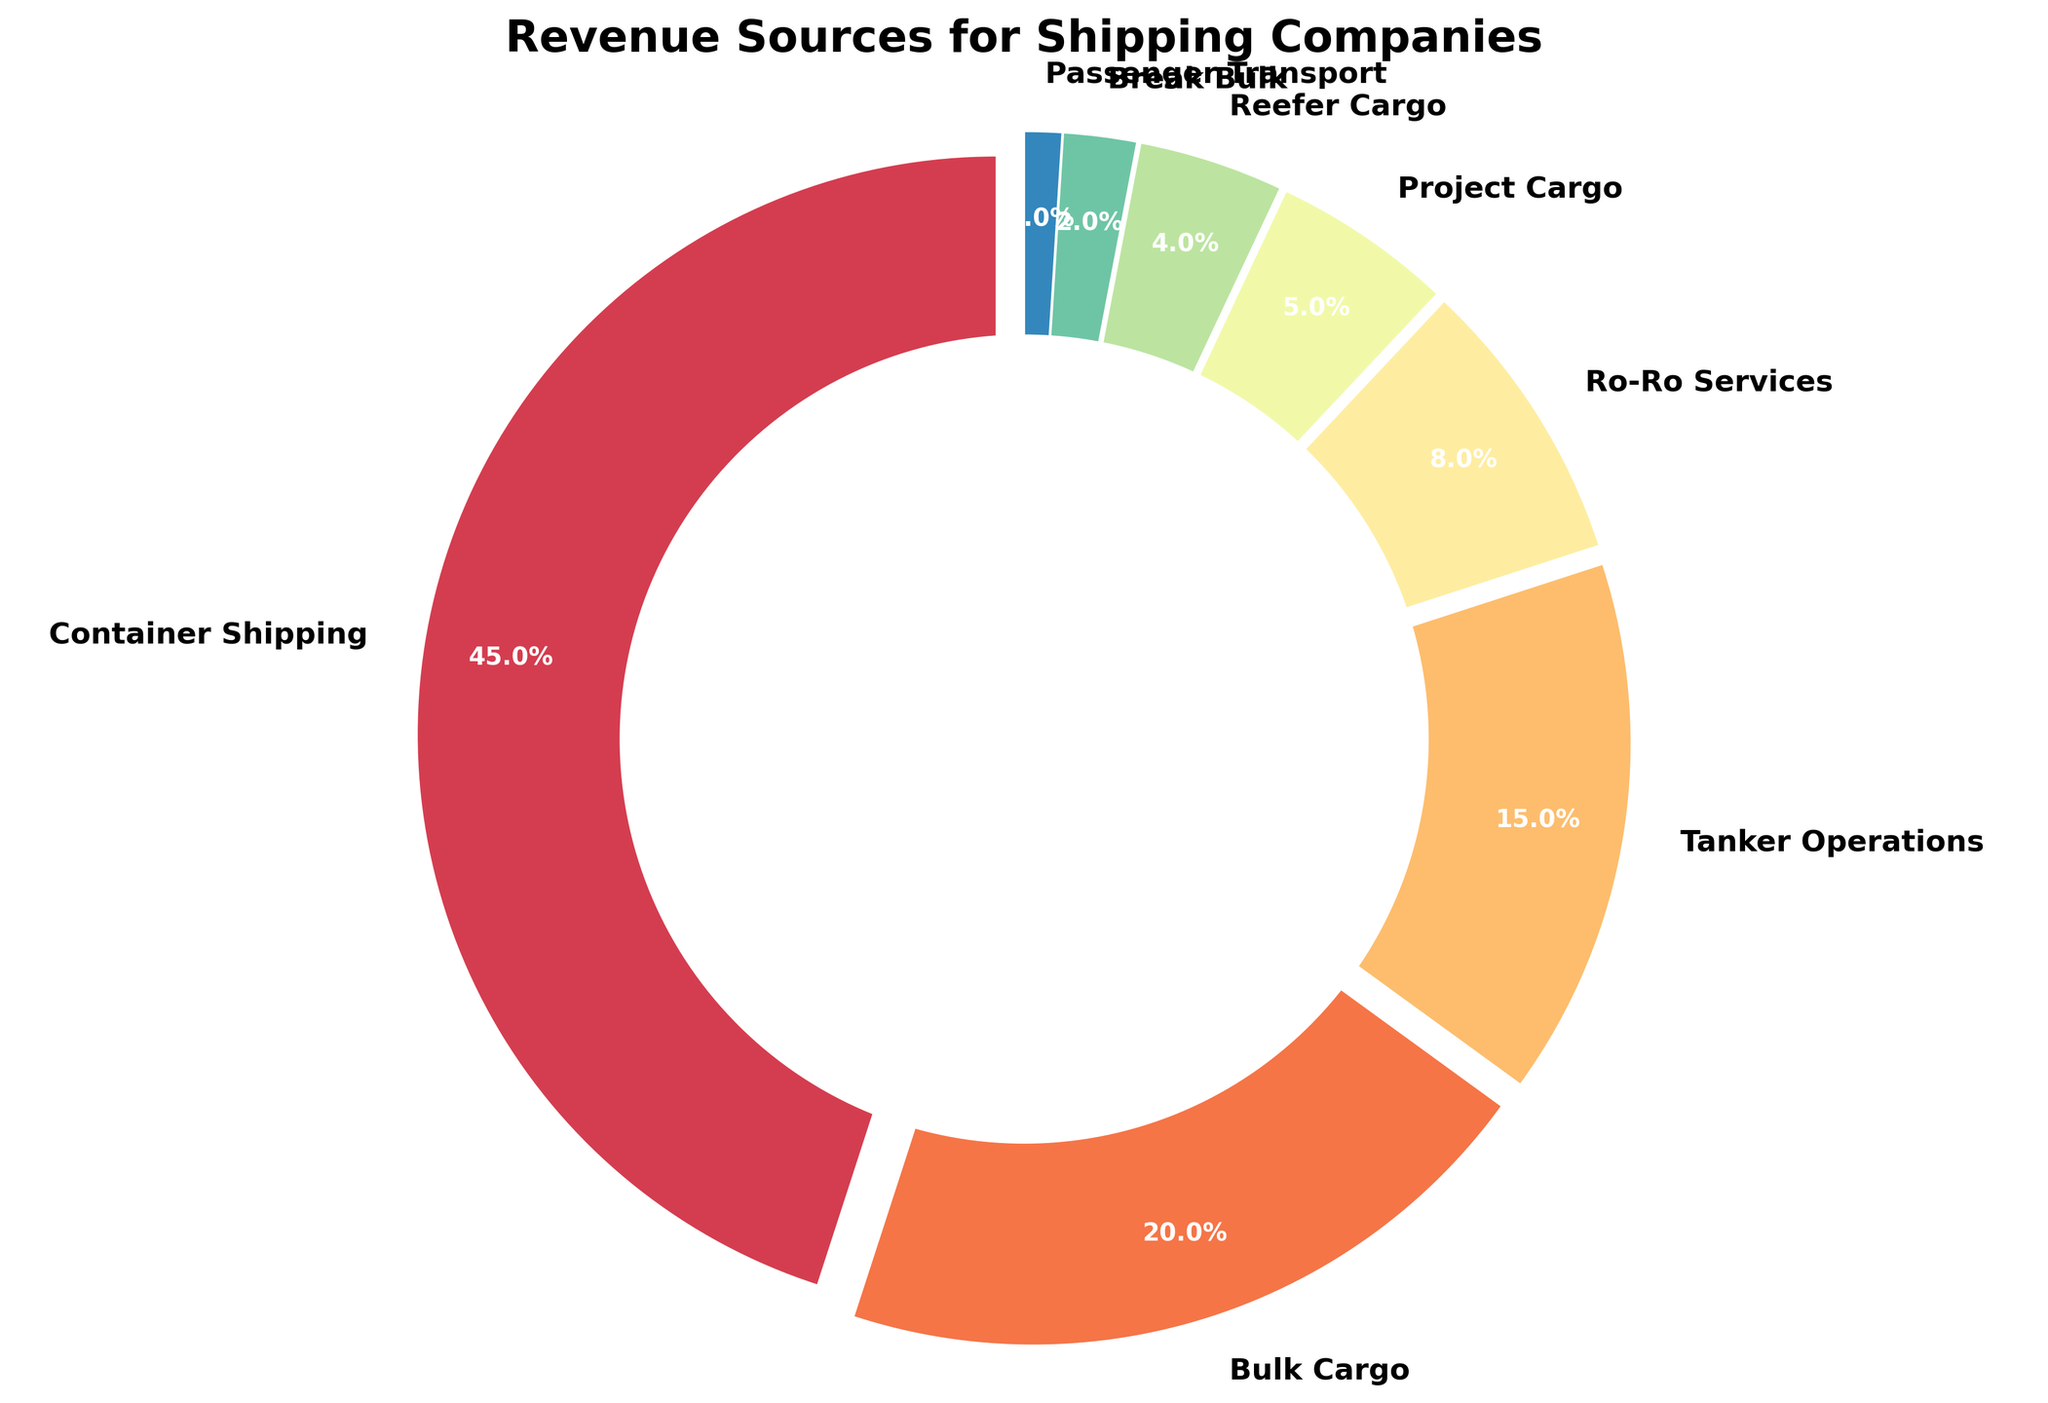What is the largest revenue source for shipping companies? Looking at the pie chart, Container Shipping has the largest slice, which shows it is the largest revenue source.
Answer: Container Shipping What percentage of revenue comes from Bulk Cargo compared to Ro-Ro Services? Bulk Cargo makes up 20% of the revenue while Ro-Ro Services account for 8%. Therefore, Bulk Cargo's share is more significant.
Answer: Bulk Cargo: 20%, Ro-Ro Services: 8% If you combine the revenue percentages of Project Cargo and Reefer Cargo, how does it compare to Tanker Operations? Project Cargo and Reefer Cargo add up to 5% + 4% = 9%. Tanker Operations alone contribute 15%, which is higher than the combined 9% of Project Cargo and Reefer Cargo.
Answer: Tanker Operations is higher What fraction of the total revenue is generated by Container Shipping and Bulk Cargo together? Container Shipping makes up 45% and Bulk Cargo accounts for 20%. Combining them gives 45% + 20% = 65%.
Answer: 65% Of the three smallest revenue sources, how much revenue do they contribute in total? The three smallest revenue sources are Break Bulk (2%), Passenger Transport (1%), and Reefer Cargo (4%). Adding these percentages, we get 2% + 1% + 4% = 7%.
Answer: 7% Which revenue source contributes less than 10% but more than 5%? When examining the pie chart, Ro-Ro Services contribute 8%, which fits in the range of less than 10% but more than 5%.
Answer: Ro-Ro Services What is the difference in revenue percentages between the largest and smallest revenue sources? The largest revenue source is Container Shipping (45%), and the smallest is Passenger Transport (1%). The difference is 45% - 1% = 44%.
Answer: 44% How do the visual attributes of the wedges help in identifying the revenue sources? The wedges in the pie chart are colored differently and have percentages labeled inside them. This helps in easily identifying and comparing the revenue sources visually.
Answer: Color and labels If revenue from Reefer Cargo increases by 50%, what would its new percentage be? Reefer Cargo currently contributes 4%. A 50% increase would be 4% * 1.50 = 6%.
Answer: 6% Compare the revenue percentage of Bulk Cargo to the combined revenue of Break Bulk and Project Cargo. Bulk Cargo contributes 20%, while Break Bulk and Project Cargo together contribute 2% + 5% = 7%. Bulk Cargo's percentage is much higher.
Answer: Bulk Cargo: 20%, Combined: 7% 